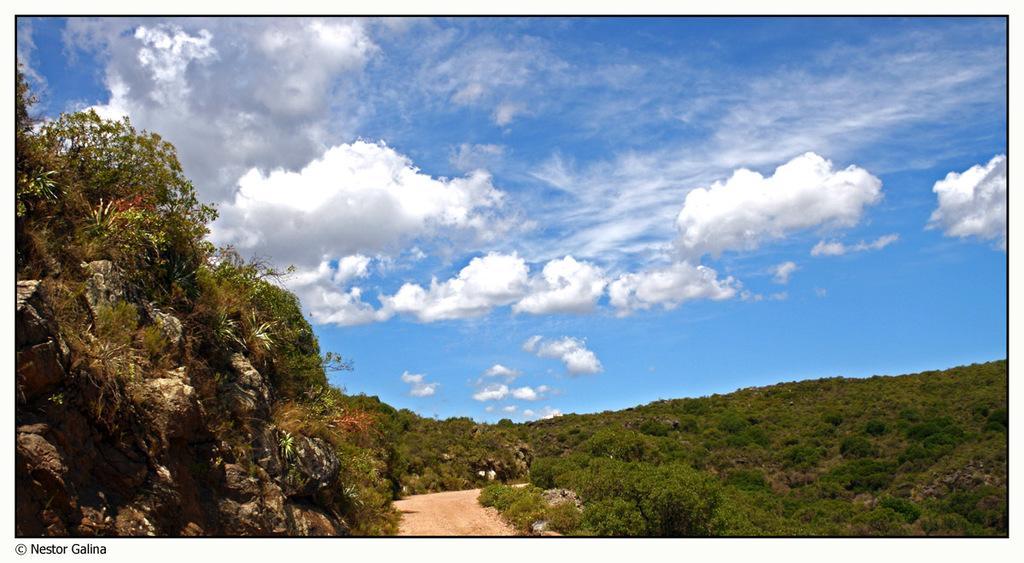Describe this image in one or two sentences. In the picture we can see trees, plants, and rocks. In the background there is sky with clouds. 